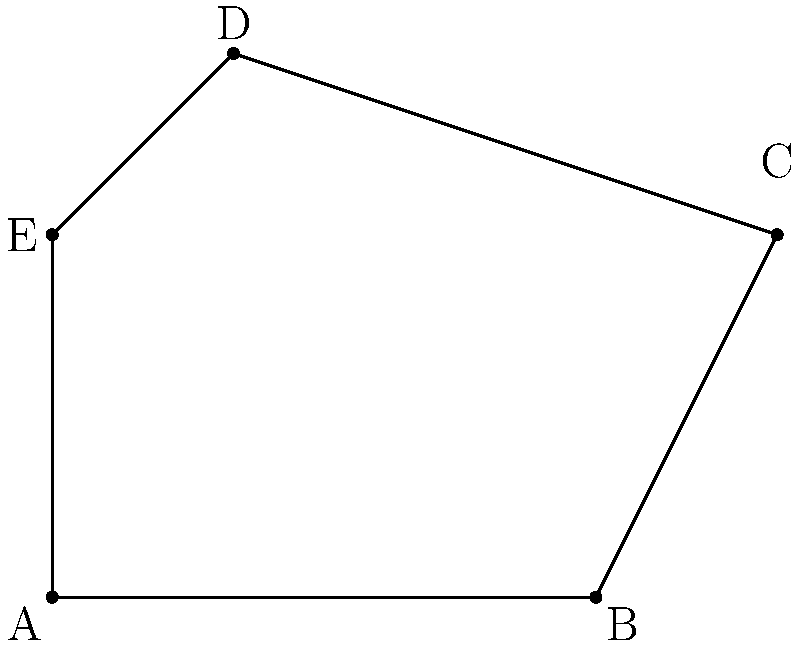During an off-road expedition, you come across an irregularly shaped clearing in a remote area. You decide to calculate its area using coordinate geometry. The clearing's boundary points are A(0,0), B(6,0), C(8,4), D(2,6), and E(0,4) on a coordinate plane where each unit represents 10 meters. What is the area of the clearing in square meters? To calculate the area of this irregular polygon, we can use the Shoelace formula (also known as the surveyor's formula). The steps are as follows:

1) The Shoelace formula for a polygon with vertices $(x_1, y_1), (x_2, y_2), ..., (x_n, y_n)$ is:

   Area = $\frac{1}{2}|((x_1y_2 + x_2y_3 + ... + x_ny_1) - (y_1x_2 + y_2x_3 + ... + y_nx_1))|$

2) For our clearing, we have:
   A(0,0), B(6,0), C(8,4), D(2,6), E(0,4)

3) Applying the formula:

   Area = $\frac{1}{2}|((0 \cdot 0 + 6 \cdot 4 + 8 \cdot 6 + 2 \cdot 4 + 0 \cdot 0) - (0 \cdot 6 + 0 \cdot 8 + 4 \cdot 2 + 6 \cdot 0 + 4 \cdot 0))|$

4) Simplifying:
   
   Area = $\frac{1}{2}|(24 + 48 + 8) - (0 + 0 + 8 + 0 + 0)|$
   
   Area = $\frac{1}{2}|80 - 8|$
   
   Area = $\frac{1}{2} \cdot 72 = 36$

5) Since each unit represents 10 meters, we need to multiply our result by $10^2 = 100$:

   Actual Area = $36 \cdot 100 = 3600$ square meters

Therefore, the area of the clearing is 3600 square meters.
Answer: 3600 square meters 